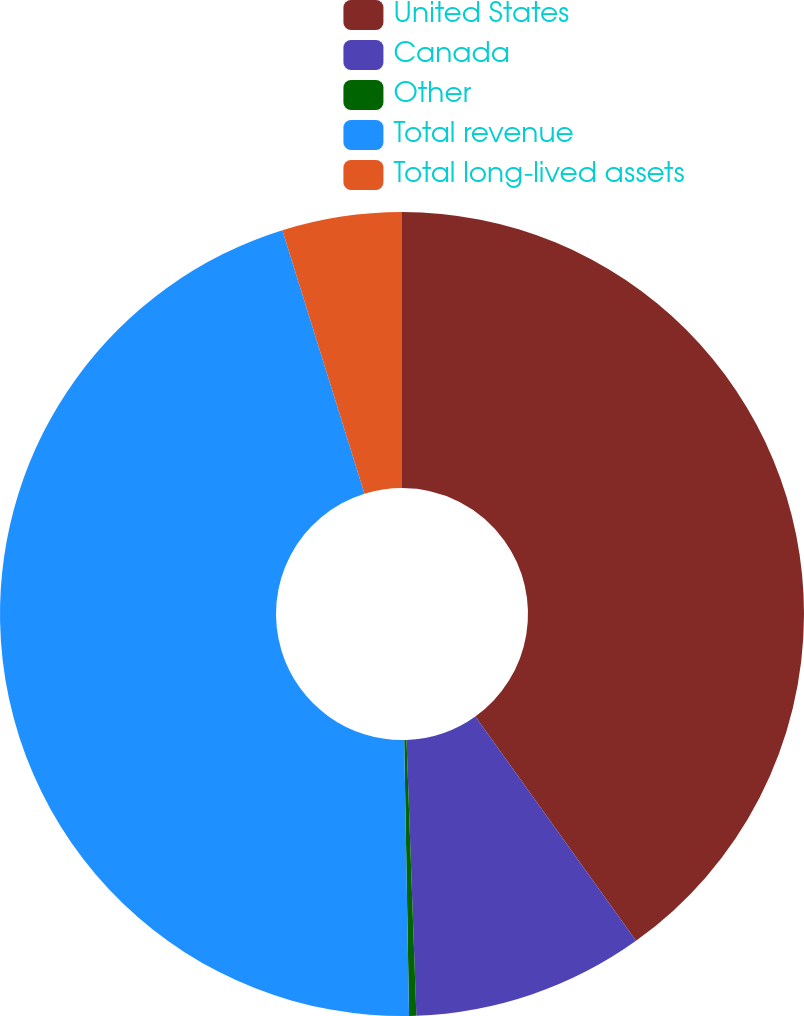Convert chart to OTSL. <chart><loc_0><loc_0><loc_500><loc_500><pie_chart><fcel>United States<fcel>Canada<fcel>Other<fcel>Total revenue<fcel>Total long-lived assets<nl><fcel>40.11%<fcel>9.32%<fcel>0.29%<fcel>45.47%<fcel>4.81%<nl></chart> 